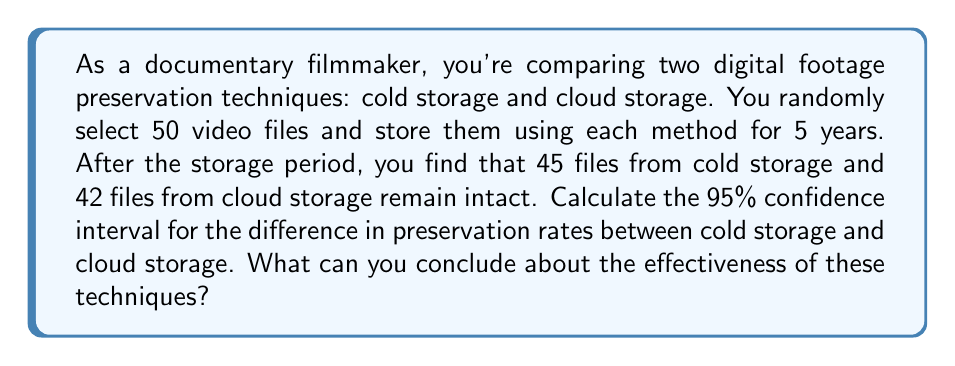Can you answer this question? Let's approach this step-by-step:

1) First, we need to calculate the sample proportions for each storage method:

   Cold storage: $p_1 = \frac{45}{50} = 0.9$
   Cloud storage: $p_2 = \frac{42}{50} = 0.84$

2) The difference in sample proportions is:
   $\hat{p_1} - \hat{p_2} = 0.9 - 0.84 = 0.06$

3) For a 95% confidence interval, we use $z_{\alpha/2} = 1.96$

4) The standard error of the difference in proportions is:

   $SE = \sqrt{\frac{\hat{p_1}(1-\hat{p_1})}{n_1} + \frac{\hat{p_2}(1-\hat{p_2})}{n_2}}$

   $SE = \sqrt{\frac{0.9(0.1)}{50} + \frac{0.84(0.16)}{50}} = \sqrt{0.0018 + 0.002688} = 0.0671$

5) The confidence interval is calculated as:

   $(\hat{p_1} - \hat{p_2}) \pm z_{\alpha/2} \cdot SE$

   $(0.06) \pm 1.96 \cdot 0.0671$

   $0.06 \pm 0.1315$

   $(-0.0715, 0.1915)$

6) Interpretation: We are 95% confident that the true difference in preservation rates between cold storage and cloud storage lies between -7.15% and 19.15%. Since this interval contains 0, we cannot conclude that there is a significant difference between the two preservation techniques at the 5% significance level.
Answer: 95% CI: (-0.0715, 0.1915); No significant difference between techniques 